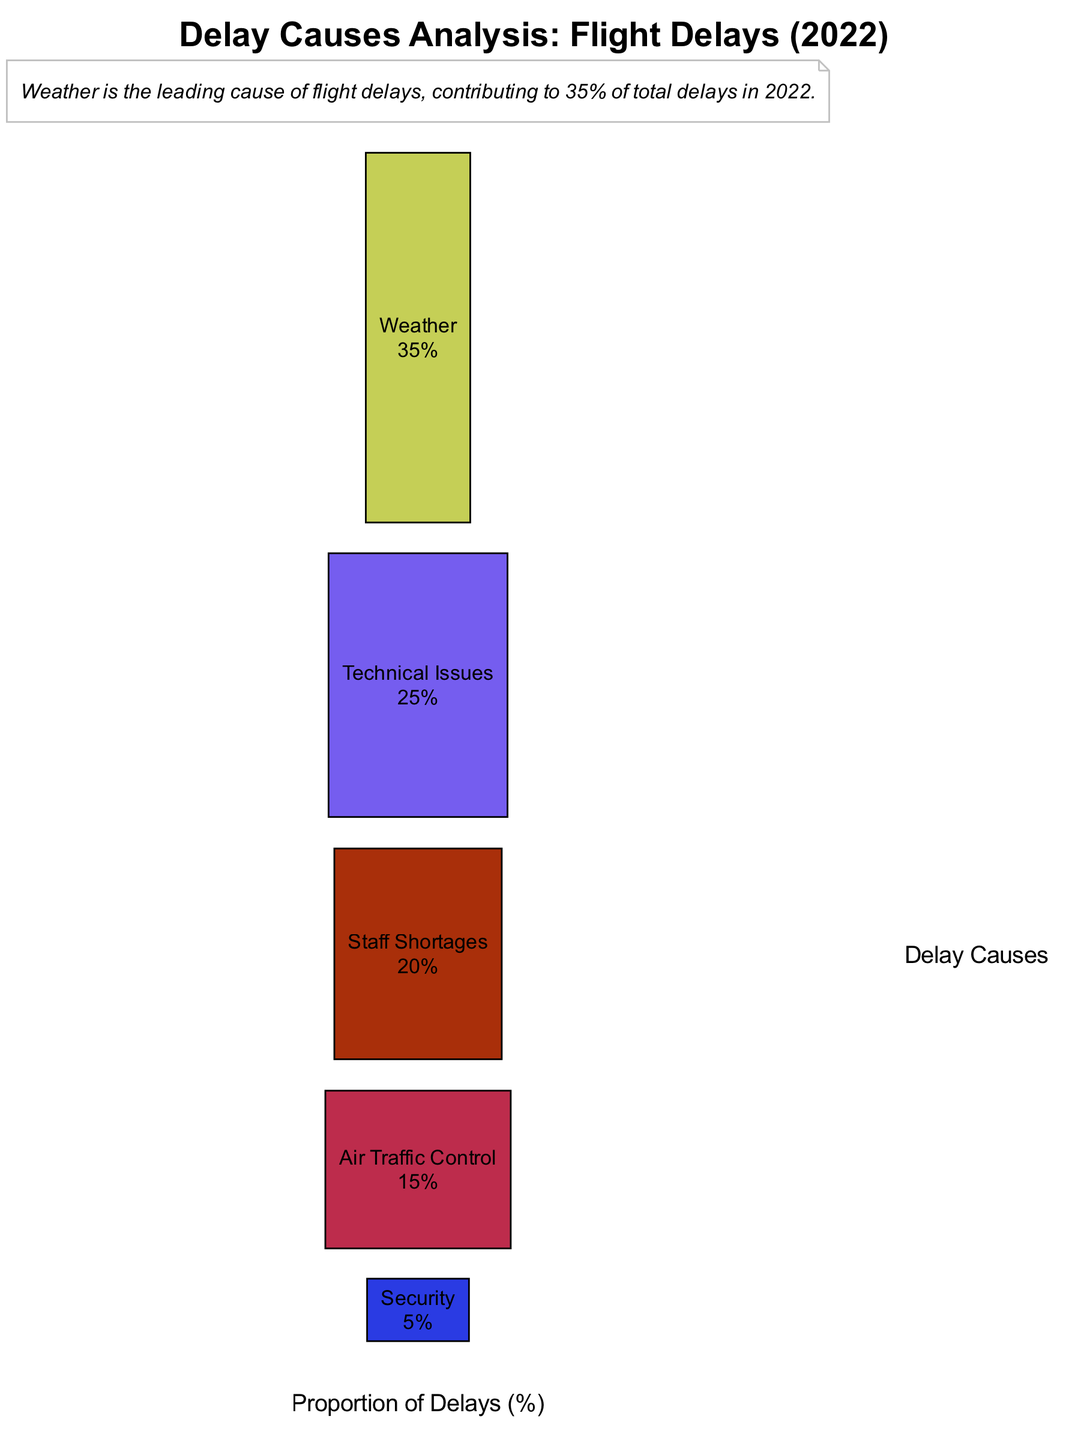What is the highest proportion of delays? The diagram indicates that "Weather" has the highest proportion at 35%, making it the leading cause of delays as shown on the y-axis with its corresponding bar.
Answer: 35% How many delay causes are represented in the diagram? The diagram lists five different delay causes; counting the bars provides the total number of categories displayed.
Answer: 5 What percentage of delays does "Security" account for? Referring to the bar corresponding to "Security," it shows that this cause accounts for 5% of the total delays as represented on the y-axis.
Answer: 5% Which delay cause has the second highest proportion? By comparing the bar heights, "Technical Issues" clearly has the second highest proportion at 25%, as seen visually in the graph.
Answer: Technical Issues What is the total percentage of delays caused by both "Staff Shortages" and "Air Traffic Control"? Adding the respective values for "Staff Shortages" (20%) and "Air Traffic Control" (15%) gives a total of 35%. This requires basic arithmetic from the values shown in the diagram.
Answer: 35% Which delay cause's proportion is closest to one-fourth of total delays? "Technical Issues" at 25% is exactly one-fourth of the total delays, making it representative of a quarter when comparing values from the graph.
Answer: Technical Issues Is "Weather" the only cause over 30%? Yes, "Weather" stands alone with a proportion of 35%, as all other causes are below this value as indicated by their respective bars on the chart.
Answer: Yes What color represents the "Air Traffic Control" delays in the diagram? By observing the diagram, the bar for "Air Traffic Control" is filled with a unique color that distinguishes it from other causes. The specific color, however, is less critical than recognizing it visually.
Answer: Unique color (specific color not defined) What does the annotation note highlight about "Weather"? The annotation specifically mentions that "Weather" is the leading cause of delays with a contribution of 35%, emphasizing its significance compared to other factors displayed.
Answer: Leading cause of delays 